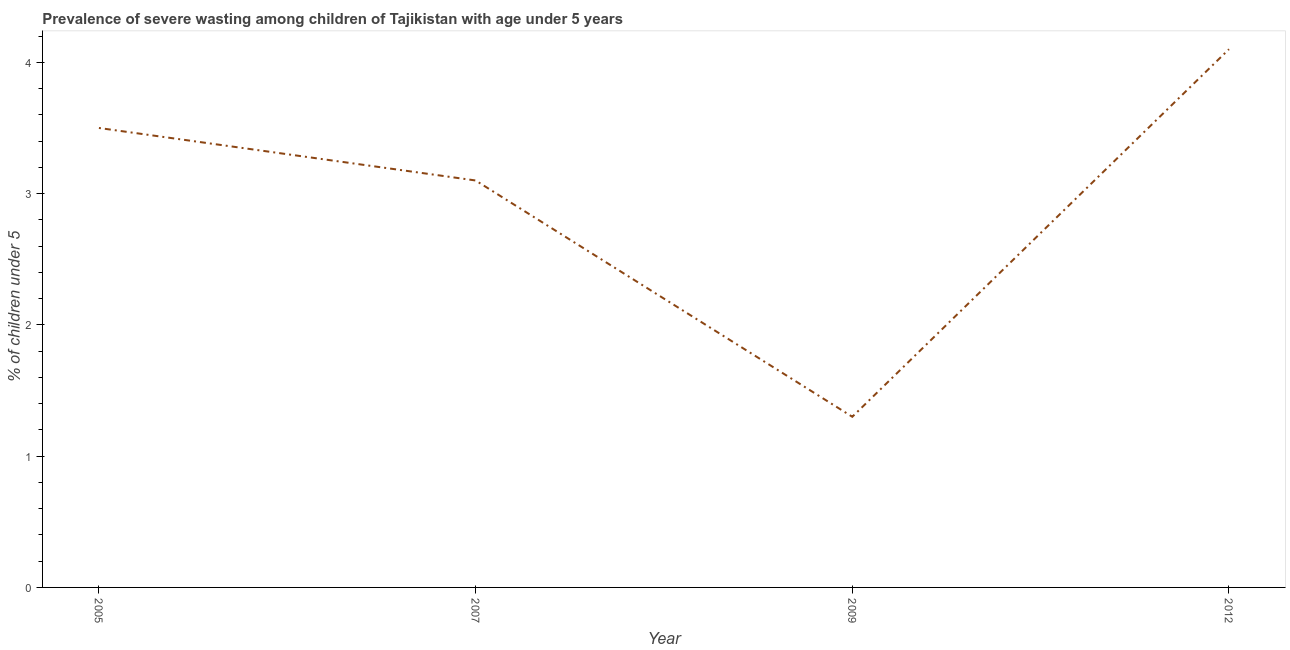What is the prevalence of severe wasting in 2012?
Give a very brief answer. 4.1. Across all years, what is the maximum prevalence of severe wasting?
Offer a terse response. 4.1. Across all years, what is the minimum prevalence of severe wasting?
Keep it short and to the point. 1.3. What is the sum of the prevalence of severe wasting?
Keep it short and to the point. 12. What is the difference between the prevalence of severe wasting in 2007 and 2009?
Give a very brief answer. 1.8. What is the average prevalence of severe wasting per year?
Offer a very short reply. 3. What is the median prevalence of severe wasting?
Offer a very short reply. 3.3. Do a majority of the years between 2005 and 2007 (inclusive) have prevalence of severe wasting greater than 2.2 %?
Your response must be concise. Yes. What is the ratio of the prevalence of severe wasting in 2005 to that in 2009?
Provide a succinct answer. 2.69. Is the prevalence of severe wasting in 2005 less than that in 2009?
Provide a short and direct response. No. What is the difference between the highest and the second highest prevalence of severe wasting?
Provide a short and direct response. 0.6. Is the sum of the prevalence of severe wasting in 2009 and 2012 greater than the maximum prevalence of severe wasting across all years?
Your answer should be very brief. Yes. What is the difference between the highest and the lowest prevalence of severe wasting?
Provide a short and direct response. 2.8. In how many years, is the prevalence of severe wasting greater than the average prevalence of severe wasting taken over all years?
Provide a succinct answer. 3. How many lines are there?
Your response must be concise. 1. What is the difference between two consecutive major ticks on the Y-axis?
Provide a short and direct response. 1. Are the values on the major ticks of Y-axis written in scientific E-notation?
Offer a terse response. No. Does the graph contain any zero values?
Keep it short and to the point. No. Does the graph contain grids?
Your response must be concise. No. What is the title of the graph?
Provide a short and direct response. Prevalence of severe wasting among children of Tajikistan with age under 5 years. What is the label or title of the Y-axis?
Your response must be concise.  % of children under 5. What is the  % of children under 5 of 2007?
Provide a short and direct response. 3.1. What is the  % of children under 5 of 2009?
Offer a very short reply. 1.3. What is the  % of children under 5 in 2012?
Your answer should be very brief. 4.1. What is the difference between the  % of children under 5 in 2005 and 2007?
Keep it short and to the point. 0.4. What is the difference between the  % of children under 5 in 2005 and 2009?
Ensure brevity in your answer.  2.2. What is the difference between the  % of children under 5 in 2007 and 2009?
Offer a very short reply. 1.8. What is the difference between the  % of children under 5 in 2007 and 2012?
Provide a short and direct response. -1. What is the ratio of the  % of children under 5 in 2005 to that in 2007?
Your answer should be compact. 1.13. What is the ratio of the  % of children under 5 in 2005 to that in 2009?
Make the answer very short. 2.69. What is the ratio of the  % of children under 5 in 2005 to that in 2012?
Provide a short and direct response. 0.85. What is the ratio of the  % of children under 5 in 2007 to that in 2009?
Ensure brevity in your answer.  2.38. What is the ratio of the  % of children under 5 in 2007 to that in 2012?
Keep it short and to the point. 0.76. What is the ratio of the  % of children under 5 in 2009 to that in 2012?
Your response must be concise. 0.32. 